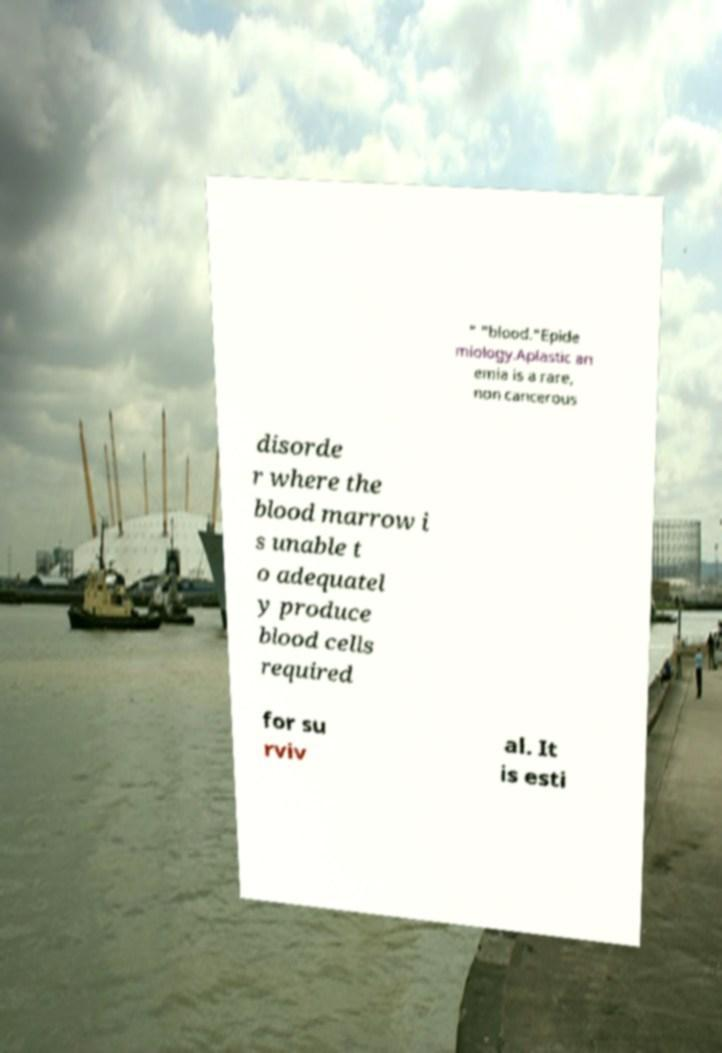I need the written content from this picture converted into text. Can you do that? " "blood."Epide miology.Aplastic an emia is a rare, non cancerous disorde r where the blood marrow i s unable t o adequatel y produce blood cells required for su rviv al. It is esti 